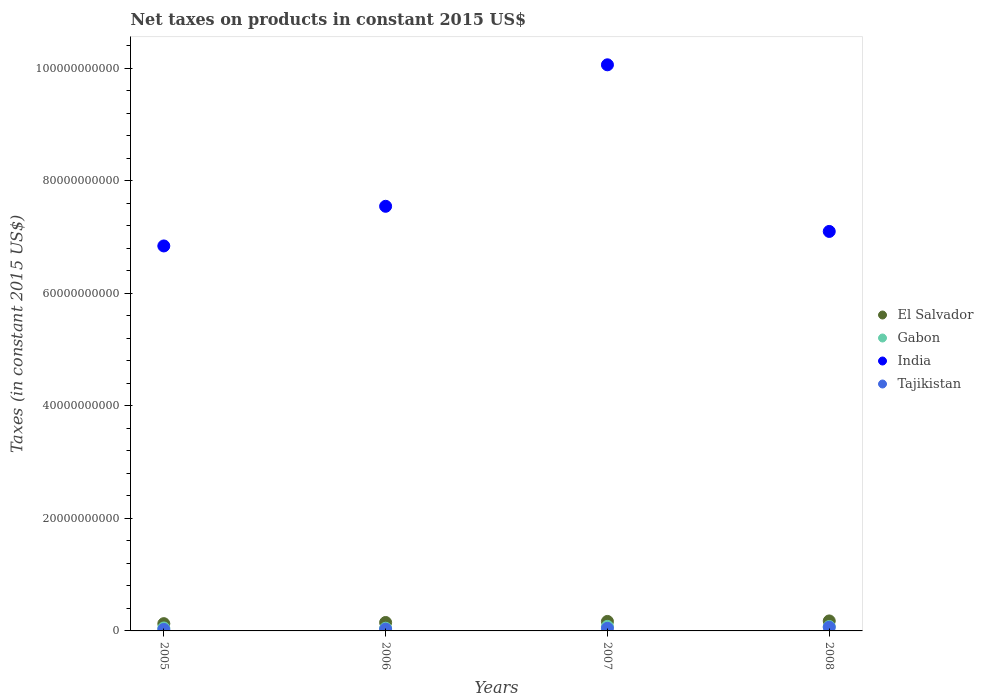What is the net taxes on products in India in 2006?
Offer a terse response. 7.55e+1. Across all years, what is the maximum net taxes on products in Tajikistan?
Your answer should be compact. 6.52e+08. Across all years, what is the minimum net taxes on products in Gabon?
Offer a terse response. 4.78e+08. What is the total net taxes on products in Tajikistan in the graph?
Your answer should be very brief. 1.71e+09. What is the difference between the net taxes on products in El Salvador in 2007 and that in 2008?
Your answer should be compact. -8.86e+07. What is the difference between the net taxes on products in India in 2005 and the net taxes on products in El Salvador in 2007?
Offer a terse response. 6.67e+1. What is the average net taxes on products in India per year?
Provide a succinct answer. 7.89e+1. In the year 2005, what is the difference between the net taxes on products in India and net taxes on products in El Salvador?
Ensure brevity in your answer.  6.71e+1. In how many years, is the net taxes on products in El Salvador greater than 4000000000 US$?
Provide a succinct answer. 0. What is the ratio of the net taxes on products in India in 2005 to that in 2006?
Keep it short and to the point. 0.91. Is the difference between the net taxes on products in India in 2005 and 2007 greater than the difference between the net taxes on products in El Salvador in 2005 and 2007?
Provide a short and direct response. No. What is the difference between the highest and the second highest net taxes on products in India?
Provide a short and direct response. 2.51e+1. What is the difference between the highest and the lowest net taxes on products in El Salvador?
Provide a short and direct response. 4.83e+08. In how many years, is the net taxes on products in Gabon greater than the average net taxes on products in Gabon taken over all years?
Your answer should be very brief. 2. Is it the case that in every year, the sum of the net taxes on products in Tajikistan and net taxes on products in India  is greater than the sum of net taxes on products in Gabon and net taxes on products in El Salvador?
Your response must be concise. Yes. Is it the case that in every year, the sum of the net taxes on products in El Salvador and net taxes on products in India  is greater than the net taxes on products in Tajikistan?
Ensure brevity in your answer.  Yes. Is the net taxes on products in Tajikistan strictly less than the net taxes on products in El Salvador over the years?
Offer a terse response. Yes. How many years are there in the graph?
Offer a very short reply. 4. Are the values on the major ticks of Y-axis written in scientific E-notation?
Ensure brevity in your answer.  No. Does the graph contain any zero values?
Your answer should be compact. No. Where does the legend appear in the graph?
Provide a succinct answer. Center right. What is the title of the graph?
Your answer should be compact. Net taxes on products in constant 2015 US$. Does "East Asia (developing only)" appear as one of the legend labels in the graph?
Provide a succinct answer. No. What is the label or title of the Y-axis?
Your answer should be very brief. Taxes (in constant 2015 US$). What is the Taxes (in constant 2015 US$) in El Salvador in 2005?
Provide a succinct answer. 1.29e+09. What is the Taxes (in constant 2015 US$) in Gabon in 2005?
Ensure brevity in your answer.  5.24e+08. What is the Taxes (in constant 2015 US$) of India in 2005?
Keep it short and to the point. 6.84e+1. What is the Taxes (in constant 2015 US$) in Tajikistan in 2005?
Your answer should be compact. 2.67e+08. What is the Taxes (in constant 2015 US$) in El Salvador in 2006?
Your answer should be very brief. 1.50e+09. What is the Taxes (in constant 2015 US$) of Gabon in 2006?
Make the answer very short. 4.78e+08. What is the Taxes (in constant 2015 US$) of India in 2006?
Offer a terse response. 7.55e+1. What is the Taxes (in constant 2015 US$) of Tajikistan in 2006?
Keep it short and to the point. 3.21e+08. What is the Taxes (in constant 2015 US$) of El Salvador in 2007?
Your answer should be very brief. 1.69e+09. What is the Taxes (in constant 2015 US$) of Gabon in 2007?
Your response must be concise. 8.05e+08. What is the Taxes (in constant 2015 US$) in India in 2007?
Your answer should be compact. 1.01e+11. What is the Taxes (in constant 2015 US$) of Tajikistan in 2007?
Make the answer very short. 4.66e+08. What is the Taxes (in constant 2015 US$) in El Salvador in 2008?
Offer a very short reply. 1.77e+09. What is the Taxes (in constant 2015 US$) of Gabon in 2008?
Provide a short and direct response. 7.82e+08. What is the Taxes (in constant 2015 US$) of India in 2008?
Offer a terse response. 7.10e+1. What is the Taxes (in constant 2015 US$) in Tajikistan in 2008?
Give a very brief answer. 6.52e+08. Across all years, what is the maximum Taxes (in constant 2015 US$) of El Salvador?
Provide a short and direct response. 1.77e+09. Across all years, what is the maximum Taxes (in constant 2015 US$) of Gabon?
Provide a short and direct response. 8.05e+08. Across all years, what is the maximum Taxes (in constant 2015 US$) in India?
Your response must be concise. 1.01e+11. Across all years, what is the maximum Taxes (in constant 2015 US$) in Tajikistan?
Ensure brevity in your answer.  6.52e+08. Across all years, what is the minimum Taxes (in constant 2015 US$) in El Salvador?
Ensure brevity in your answer.  1.29e+09. Across all years, what is the minimum Taxes (in constant 2015 US$) of Gabon?
Ensure brevity in your answer.  4.78e+08. Across all years, what is the minimum Taxes (in constant 2015 US$) in India?
Make the answer very short. 6.84e+1. Across all years, what is the minimum Taxes (in constant 2015 US$) of Tajikistan?
Keep it short and to the point. 2.67e+08. What is the total Taxes (in constant 2015 US$) in El Salvador in the graph?
Provide a succinct answer. 6.25e+09. What is the total Taxes (in constant 2015 US$) of Gabon in the graph?
Your answer should be very brief. 2.59e+09. What is the total Taxes (in constant 2015 US$) in India in the graph?
Make the answer very short. 3.15e+11. What is the total Taxes (in constant 2015 US$) in Tajikistan in the graph?
Provide a succinct answer. 1.71e+09. What is the difference between the Taxes (in constant 2015 US$) in El Salvador in 2005 and that in 2006?
Your answer should be compact. -2.07e+08. What is the difference between the Taxes (in constant 2015 US$) of Gabon in 2005 and that in 2006?
Provide a short and direct response. 4.63e+07. What is the difference between the Taxes (in constant 2015 US$) of India in 2005 and that in 2006?
Provide a short and direct response. -7.05e+09. What is the difference between the Taxes (in constant 2015 US$) of Tajikistan in 2005 and that in 2006?
Your answer should be very brief. -5.46e+07. What is the difference between the Taxes (in constant 2015 US$) of El Salvador in 2005 and that in 2007?
Your answer should be compact. -3.94e+08. What is the difference between the Taxes (in constant 2015 US$) of Gabon in 2005 and that in 2007?
Your answer should be very brief. -2.81e+08. What is the difference between the Taxes (in constant 2015 US$) of India in 2005 and that in 2007?
Keep it short and to the point. -3.22e+1. What is the difference between the Taxes (in constant 2015 US$) in Tajikistan in 2005 and that in 2007?
Give a very brief answer. -1.99e+08. What is the difference between the Taxes (in constant 2015 US$) of El Salvador in 2005 and that in 2008?
Make the answer very short. -4.83e+08. What is the difference between the Taxes (in constant 2015 US$) of Gabon in 2005 and that in 2008?
Give a very brief answer. -2.58e+08. What is the difference between the Taxes (in constant 2015 US$) of India in 2005 and that in 2008?
Give a very brief answer. -2.58e+09. What is the difference between the Taxes (in constant 2015 US$) in Tajikistan in 2005 and that in 2008?
Your answer should be compact. -3.85e+08. What is the difference between the Taxes (in constant 2015 US$) of El Salvador in 2006 and that in 2007?
Offer a terse response. -1.87e+08. What is the difference between the Taxes (in constant 2015 US$) of Gabon in 2006 and that in 2007?
Give a very brief answer. -3.27e+08. What is the difference between the Taxes (in constant 2015 US$) of India in 2006 and that in 2007?
Make the answer very short. -2.51e+1. What is the difference between the Taxes (in constant 2015 US$) of Tajikistan in 2006 and that in 2007?
Keep it short and to the point. -1.45e+08. What is the difference between the Taxes (in constant 2015 US$) of El Salvador in 2006 and that in 2008?
Make the answer very short. -2.76e+08. What is the difference between the Taxes (in constant 2015 US$) in Gabon in 2006 and that in 2008?
Give a very brief answer. -3.04e+08. What is the difference between the Taxes (in constant 2015 US$) of India in 2006 and that in 2008?
Offer a terse response. 4.47e+09. What is the difference between the Taxes (in constant 2015 US$) in Tajikistan in 2006 and that in 2008?
Offer a very short reply. -3.30e+08. What is the difference between the Taxes (in constant 2015 US$) of El Salvador in 2007 and that in 2008?
Offer a terse response. -8.86e+07. What is the difference between the Taxes (in constant 2015 US$) in Gabon in 2007 and that in 2008?
Offer a terse response. 2.26e+07. What is the difference between the Taxes (in constant 2015 US$) of India in 2007 and that in 2008?
Provide a short and direct response. 2.96e+1. What is the difference between the Taxes (in constant 2015 US$) of Tajikistan in 2007 and that in 2008?
Provide a short and direct response. -1.86e+08. What is the difference between the Taxes (in constant 2015 US$) in El Salvador in 2005 and the Taxes (in constant 2015 US$) in Gabon in 2006?
Your response must be concise. 8.13e+08. What is the difference between the Taxes (in constant 2015 US$) of El Salvador in 2005 and the Taxes (in constant 2015 US$) of India in 2006?
Provide a short and direct response. -7.42e+1. What is the difference between the Taxes (in constant 2015 US$) of El Salvador in 2005 and the Taxes (in constant 2015 US$) of Tajikistan in 2006?
Your answer should be compact. 9.70e+08. What is the difference between the Taxes (in constant 2015 US$) in Gabon in 2005 and the Taxes (in constant 2015 US$) in India in 2006?
Offer a terse response. -7.49e+1. What is the difference between the Taxes (in constant 2015 US$) of Gabon in 2005 and the Taxes (in constant 2015 US$) of Tajikistan in 2006?
Offer a terse response. 2.03e+08. What is the difference between the Taxes (in constant 2015 US$) of India in 2005 and the Taxes (in constant 2015 US$) of Tajikistan in 2006?
Provide a succinct answer. 6.81e+1. What is the difference between the Taxes (in constant 2015 US$) of El Salvador in 2005 and the Taxes (in constant 2015 US$) of Gabon in 2007?
Provide a short and direct response. 4.86e+08. What is the difference between the Taxes (in constant 2015 US$) of El Salvador in 2005 and the Taxes (in constant 2015 US$) of India in 2007?
Provide a short and direct response. -9.93e+1. What is the difference between the Taxes (in constant 2015 US$) of El Salvador in 2005 and the Taxes (in constant 2015 US$) of Tajikistan in 2007?
Keep it short and to the point. 8.25e+08. What is the difference between the Taxes (in constant 2015 US$) in Gabon in 2005 and the Taxes (in constant 2015 US$) in India in 2007?
Make the answer very short. -1.00e+11. What is the difference between the Taxes (in constant 2015 US$) of Gabon in 2005 and the Taxes (in constant 2015 US$) of Tajikistan in 2007?
Give a very brief answer. 5.85e+07. What is the difference between the Taxes (in constant 2015 US$) in India in 2005 and the Taxes (in constant 2015 US$) in Tajikistan in 2007?
Keep it short and to the point. 6.79e+1. What is the difference between the Taxes (in constant 2015 US$) in El Salvador in 2005 and the Taxes (in constant 2015 US$) in Gabon in 2008?
Offer a very short reply. 5.09e+08. What is the difference between the Taxes (in constant 2015 US$) in El Salvador in 2005 and the Taxes (in constant 2015 US$) in India in 2008?
Keep it short and to the point. -6.97e+1. What is the difference between the Taxes (in constant 2015 US$) in El Salvador in 2005 and the Taxes (in constant 2015 US$) in Tajikistan in 2008?
Provide a short and direct response. 6.39e+08. What is the difference between the Taxes (in constant 2015 US$) of Gabon in 2005 and the Taxes (in constant 2015 US$) of India in 2008?
Your answer should be very brief. -7.05e+1. What is the difference between the Taxes (in constant 2015 US$) of Gabon in 2005 and the Taxes (in constant 2015 US$) of Tajikistan in 2008?
Offer a terse response. -1.27e+08. What is the difference between the Taxes (in constant 2015 US$) of India in 2005 and the Taxes (in constant 2015 US$) of Tajikistan in 2008?
Make the answer very short. 6.78e+1. What is the difference between the Taxes (in constant 2015 US$) of El Salvador in 2006 and the Taxes (in constant 2015 US$) of Gabon in 2007?
Your answer should be compact. 6.94e+08. What is the difference between the Taxes (in constant 2015 US$) in El Salvador in 2006 and the Taxes (in constant 2015 US$) in India in 2007?
Offer a very short reply. -9.91e+1. What is the difference between the Taxes (in constant 2015 US$) in El Salvador in 2006 and the Taxes (in constant 2015 US$) in Tajikistan in 2007?
Offer a very short reply. 1.03e+09. What is the difference between the Taxes (in constant 2015 US$) of Gabon in 2006 and the Taxes (in constant 2015 US$) of India in 2007?
Offer a terse response. -1.00e+11. What is the difference between the Taxes (in constant 2015 US$) in Gabon in 2006 and the Taxes (in constant 2015 US$) in Tajikistan in 2007?
Offer a terse response. 1.22e+07. What is the difference between the Taxes (in constant 2015 US$) in India in 2006 and the Taxes (in constant 2015 US$) in Tajikistan in 2007?
Provide a succinct answer. 7.50e+1. What is the difference between the Taxes (in constant 2015 US$) of El Salvador in 2006 and the Taxes (in constant 2015 US$) of Gabon in 2008?
Your answer should be very brief. 7.16e+08. What is the difference between the Taxes (in constant 2015 US$) of El Salvador in 2006 and the Taxes (in constant 2015 US$) of India in 2008?
Your response must be concise. -6.95e+1. What is the difference between the Taxes (in constant 2015 US$) of El Salvador in 2006 and the Taxes (in constant 2015 US$) of Tajikistan in 2008?
Ensure brevity in your answer.  8.47e+08. What is the difference between the Taxes (in constant 2015 US$) in Gabon in 2006 and the Taxes (in constant 2015 US$) in India in 2008?
Provide a short and direct response. -7.05e+1. What is the difference between the Taxes (in constant 2015 US$) of Gabon in 2006 and the Taxes (in constant 2015 US$) of Tajikistan in 2008?
Ensure brevity in your answer.  -1.74e+08. What is the difference between the Taxes (in constant 2015 US$) of India in 2006 and the Taxes (in constant 2015 US$) of Tajikistan in 2008?
Keep it short and to the point. 7.48e+1. What is the difference between the Taxes (in constant 2015 US$) of El Salvador in 2007 and the Taxes (in constant 2015 US$) of Gabon in 2008?
Ensure brevity in your answer.  9.03e+08. What is the difference between the Taxes (in constant 2015 US$) in El Salvador in 2007 and the Taxes (in constant 2015 US$) in India in 2008?
Offer a very short reply. -6.93e+1. What is the difference between the Taxes (in constant 2015 US$) in El Salvador in 2007 and the Taxes (in constant 2015 US$) in Tajikistan in 2008?
Your response must be concise. 1.03e+09. What is the difference between the Taxes (in constant 2015 US$) of Gabon in 2007 and the Taxes (in constant 2015 US$) of India in 2008?
Provide a succinct answer. -7.02e+1. What is the difference between the Taxes (in constant 2015 US$) in Gabon in 2007 and the Taxes (in constant 2015 US$) in Tajikistan in 2008?
Your response must be concise. 1.53e+08. What is the difference between the Taxes (in constant 2015 US$) of India in 2007 and the Taxes (in constant 2015 US$) of Tajikistan in 2008?
Your answer should be compact. 9.99e+1. What is the average Taxes (in constant 2015 US$) of El Salvador per year?
Provide a short and direct response. 1.56e+09. What is the average Taxes (in constant 2015 US$) of Gabon per year?
Offer a terse response. 6.47e+08. What is the average Taxes (in constant 2015 US$) of India per year?
Give a very brief answer. 7.89e+1. What is the average Taxes (in constant 2015 US$) of Tajikistan per year?
Offer a terse response. 4.26e+08. In the year 2005, what is the difference between the Taxes (in constant 2015 US$) in El Salvador and Taxes (in constant 2015 US$) in Gabon?
Your answer should be compact. 7.67e+08. In the year 2005, what is the difference between the Taxes (in constant 2015 US$) of El Salvador and Taxes (in constant 2015 US$) of India?
Your response must be concise. -6.71e+1. In the year 2005, what is the difference between the Taxes (in constant 2015 US$) of El Salvador and Taxes (in constant 2015 US$) of Tajikistan?
Provide a short and direct response. 1.02e+09. In the year 2005, what is the difference between the Taxes (in constant 2015 US$) in Gabon and Taxes (in constant 2015 US$) in India?
Make the answer very short. -6.79e+1. In the year 2005, what is the difference between the Taxes (in constant 2015 US$) of Gabon and Taxes (in constant 2015 US$) of Tajikistan?
Make the answer very short. 2.58e+08. In the year 2005, what is the difference between the Taxes (in constant 2015 US$) in India and Taxes (in constant 2015 US$) in Tajikistan?
Give a very brief answer. 6.81e+1. In the year 2006, what is the difference between the Taxes (in constant 2015 US$) in El Salvador and Taxes (in constant 2015 US$) in Gabon?
Make the answer very short. 1.02e+09. In the year 2006, what is the difference between the Taxes (in constant 2015 US$) of El Salvador and Taxes (in constant 2015 US$) of India?
Your answer should be compact. -7.40e+1. In the year 2006, what is the difference between the Taxes (in constant 2015 US$) of El Salvador and Taxes (in constant 2015 US$) of Tajikistan?
Ensure brevity in your answer.  1.18e+09. In the year 2006, what is the difference between the Taxes (in constant 2015 US$) of Gabon and Taxes (in constant 2015 US$) of India?
Offer a very short reply. -7.50e+1. In the year 2006, what is the difference between the Taxes (in constant 2015 US$) in Gabon and Taxes (in constant 2015 US$) in Tajikistan?
Provide a succinct answer. 1.57e+08. In the year 2006, what is the difference between the Taxes (in constant 2015 US$) in India and Taxes (in constant 2015 US$) in Tajikistan?
Provide a succinct answer. 7.51e+1. In the year 2007, what is the difference between the Taxes (in constant 2015 US$) of El Salvador and Taxes (in constant 2015 US$) of Gabon?
Make the answer very short. 8.81e+08. In the year 2007, what is the difference between the Taxes (in constant 2015 US$) in El Salvador and Taxes (in constant 2015 US$) in India?
Make the answer very short. -9.89e+1. In the year 2007, what is the difference between the Taxes (in constant 2015 US$) in El Salvador and Taxes (in constant 2015 US$) in Tajikistan?
Offer a very short reply. 1.22e+09. In the year 2007, what is the difference between the Taxes (in constant 2015 US$) of Gabon and Taxes (in constant 2015 US$) of India?
Make the answer very short. -9.98e+1. In the year 2007, what is the difference between the Taxes (in constant 2015 US$) of Gabon and Taxes (in constant 2015 US$) of Tajikistan?
Ensure brevity in your answer.  3.39e+08. In the year 2007, what is the difference between the Taxes (in constant 2015 US$) in India and Taxes (in constant 2015 US$) in Tajikistan?
Provide a short and direct response. 1.00e+11. In the year 2008, what is the difference between the Taxes (in constant 2015 US$) of El Salvador and Taxes (in constant 2015 US$) of Gabon?
Make the answer very short. 9.92e+08. In the year 2008, what is the difference between the Taxes (in constant 2015 US$) of El Salvador and Taxes (in constant 2015 US$) of India?
Your answer should be compact. -6.92e+1. In the year 2008, what is the difference between the Taxes (in constant 2015 US$) in El Salvador and Taxes (in constant 2015 US$) in Tajikistan?
Provide a short and direct response. 1.12e+09. In the year 2008, what is the difference between the Taxes (in constant 2015 US$) of Gabon and Taxes (in constant 2015 US$) of India?
Make the answer very short. -7.02e+1. In the year 2008, what is the difference between the Taxes (in constant 2015 US$) of Gabon and Taxes (in constant 2015 US$) of Tajikistan?
Provide a succinct answer. 1.31e+08. In the year 2008, what is the difference between the Taxes (in constant 2015 US$) in India and Taxes (in constant 2015 US$) in Tajikistan?
Your answer should be very brief. 7.03e+1. What is the ratio of the Taxes (in constant 2015 US$) of El Salvador in 2005 to that in 2006?
Offer a terse response. 0.86. What is the ratio of the Taxes (in constant 2015 US$) in Gabon in 2005 to that in 2006?
Your answer should be compact. 1.1. What is the ratio of the Taxes (in constant 2015 US$) in India in 2005 to that in 2006?
Your answer should be very brief. 0.91. What is the ratio of the Taxes (in constant 2015 US$) in Tajikistan in 2005 to that in 2006?
Make the answer very short. 0.83. What is the ratio of the Taxes (in constant 2015 US$) of El Salvador in 2005 to that in 2007?
Keep it short and to the point. 0.77. What is the ratio of the Taxes (in constant 2015 US$) in Gabon in 2005 to that in 2007?
Make the answer very short. 0.65. What is the ratio of the Taxes (in constant 2015 US$) of India in 2005 to that in 2007?
Ensure brevity in your answer.  0.68. What is the ratio of the Taxes (in constant 2015 US$) in Tajikistan in 2005 to that in 2007?
Offer a terse response. 0.57. What is the ratio of the Taxes (in constant 2015 US$) of El Salvador in 2005 to that in 2008?
Keep it short and to the point. 0.73. What is the ratio of the Taxes (in constant 2015 US$) in Gabon in 2005 to that in 2008?
Ensure brevity in your answer.  0.67. What is the ratio of the Taxes (in constant 2015 US$) of India in 2005 to that in 2008?
Your answer should be very brief. 0.96. What is the ratio of the Taxes (in constant 2015 US$) in Tajikistan in 2005 to that in 2008?
Ensure brevity in your answer.  0.41. What is the ratio of the Taxes (in constant 2015 US$) of El Salvador in 2006 to that in 2007?
Ensure brevity in your answer.  0.89. What is the ratio of the Taxes (in constant 2015 US$) of Gabon in 2006 to that in 2007?
Ensure brevity in your answer.  0.59. What is the ratio of the Taxes (in constant 2015 US$) of India in 2006 to that in 2007?
Ensure brevity in your answer.  0.75. What is the ratio of the Taxes (in constant 2015 US$) in Tajikistan in 2006 to that in 2007?
Offer a very short reply. 0.69. What is the ratio of the Taxes (in constant 2015 US$) in El Salvador in 2006 to that in 2008?
Provide a succinct answer. 0.84. What is the ratio of the Taxes (in constant 2015 US$) of Gabon in 2006 to that in 2008?
Your response must be concise. 0.61. What is the ratio of the Taxes (in constant 2015 US$) of India in 2006 to that in 2008?
Give a very brief answer. 1.06. What is the ratio of the Taxes (in constant 2015 US$) of Tajikistan in 2006 to that in 2008?
Your answer should be very brief. 0.49. What is the ratio of the Taxes (in constant 2015 US$) of El Salvador in 2007 to that in 2008?
Offer a very short reply. 0.95. What is the ratio of the Taxes (in constant 2015 US$) of Gabon in 2007 to that in 2008?
Provide a short and direct response. 1.03. What is the ratio of the Taxes (in constant 2015 US$) in India in 2007 to that in 2008?
Give a very brief answer. 1.42. What is the ratio of the Taxes (in constant 2015 US$) in Tajikistan in 2007 to that in 2008?
Your response must be concise. 0.71. What is the difference between the highest and the second highest Taxes (in constant 2015 US$) in El Salvador?
Provide a succinct answer. 8.86e+07. What is the difference between the highest and the second highest Taxes (in constant 2015 US$) in Gabon?
Offer a terse response. 2.26e+07. What is the difference between the highest and the second highest Taxes (in constant 2015 US$) of India?
Offer a terse response. 2.51e+1. What is the difference between the highest and the second highest Taxes (in constant 2015 US$) of Tajikistan?
Ensure brevity in your answer.  1.86e+08. What is the difference between the highest and the lowest Taxes (in constant 2015 US$) in El Salvador?
Offer a terse response. 4.83e+08. What is the difference between the highest and the lowest Taxes (in constant 2015 US$) of Gabon?
Ensure brevity in your answer.  3.27e+08. What is the difference between the highest and the lowest Taxes (in constant 2015 US$) of India?
Provide a short and direct response. 3.22e+1. What is the difference between the highest and the lowest Taxes (in constant 2015 US$) of Tajikistan?
Offer a terse response. 3.85e+08. 